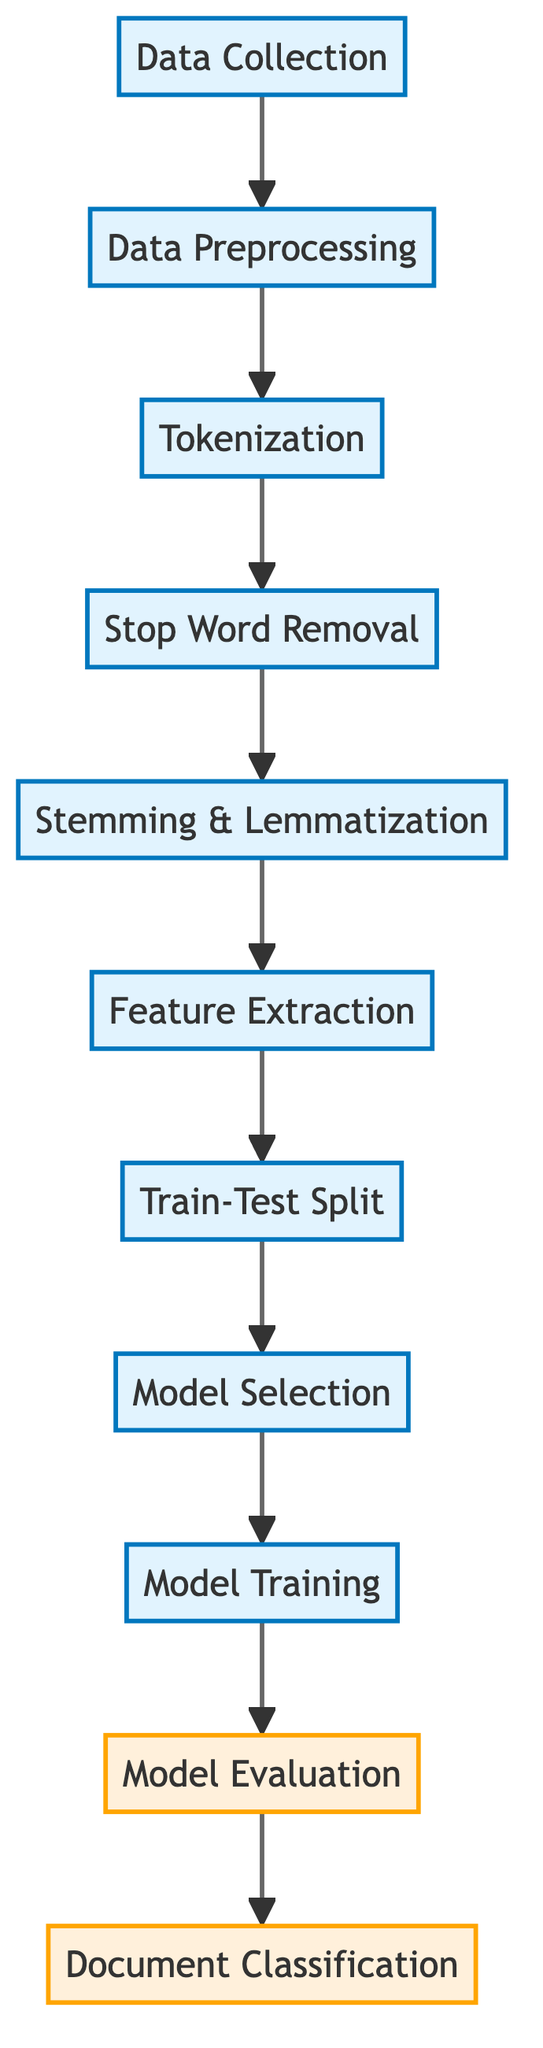What is the first step in the process? The diagram shows "Data Collection" as the first node in the flow. This indicates that the process begins with collecting the relevant legal documents.
Answer: Data Collection How many processes are involved in the data preprocessing stage? In the diagram, the data preprocessing includes four distinct steps: Tokenization, Stop Word Removal, and Stemming & Lemmatization. This makes a total of three processes before moving to feature extraction.
Answer: Three What comes after feature extraction? The flowchart indicates that after "Feature Extraction," the next step is "Train-Test Split," demonstrating the sequence in the machine learning workflow.
Answer: Train-Test Split What type of evaluation occurs after model training? According to the diagram, following the "Model Training" step is "Model Evaluation," which assesses the performance of the trained model using the prepared data.
Answer: Model Evaluation Which step requires division of data? The diagram highlights "Train-Test Split," as a distinct process that involves dividing the collected data into training and testing sets for the model.
Answer: Train-Test Split How many nodes are labeled as evaluation in the diagram? The diagram shows two nodes labeled as evaluation: "Model Evaluation" and "Document Classification," indicating these are the end-stage assessments.
Answer: Two What is the relationship between tokenization and stop word removal? The diagram shows a direct sequential link from "Tokenization" to "Stop Word Removal," indicating that stop word removal immediately follows tokenization in the preprocessing stage.
Answer: Sequential link What is the final output of this machine learning model workflow? Per the diagram, the ultimate output of the entire process is "Document Classification," which is the end goal of categorizing legal documents based on their content.
Answer: Document Classification 